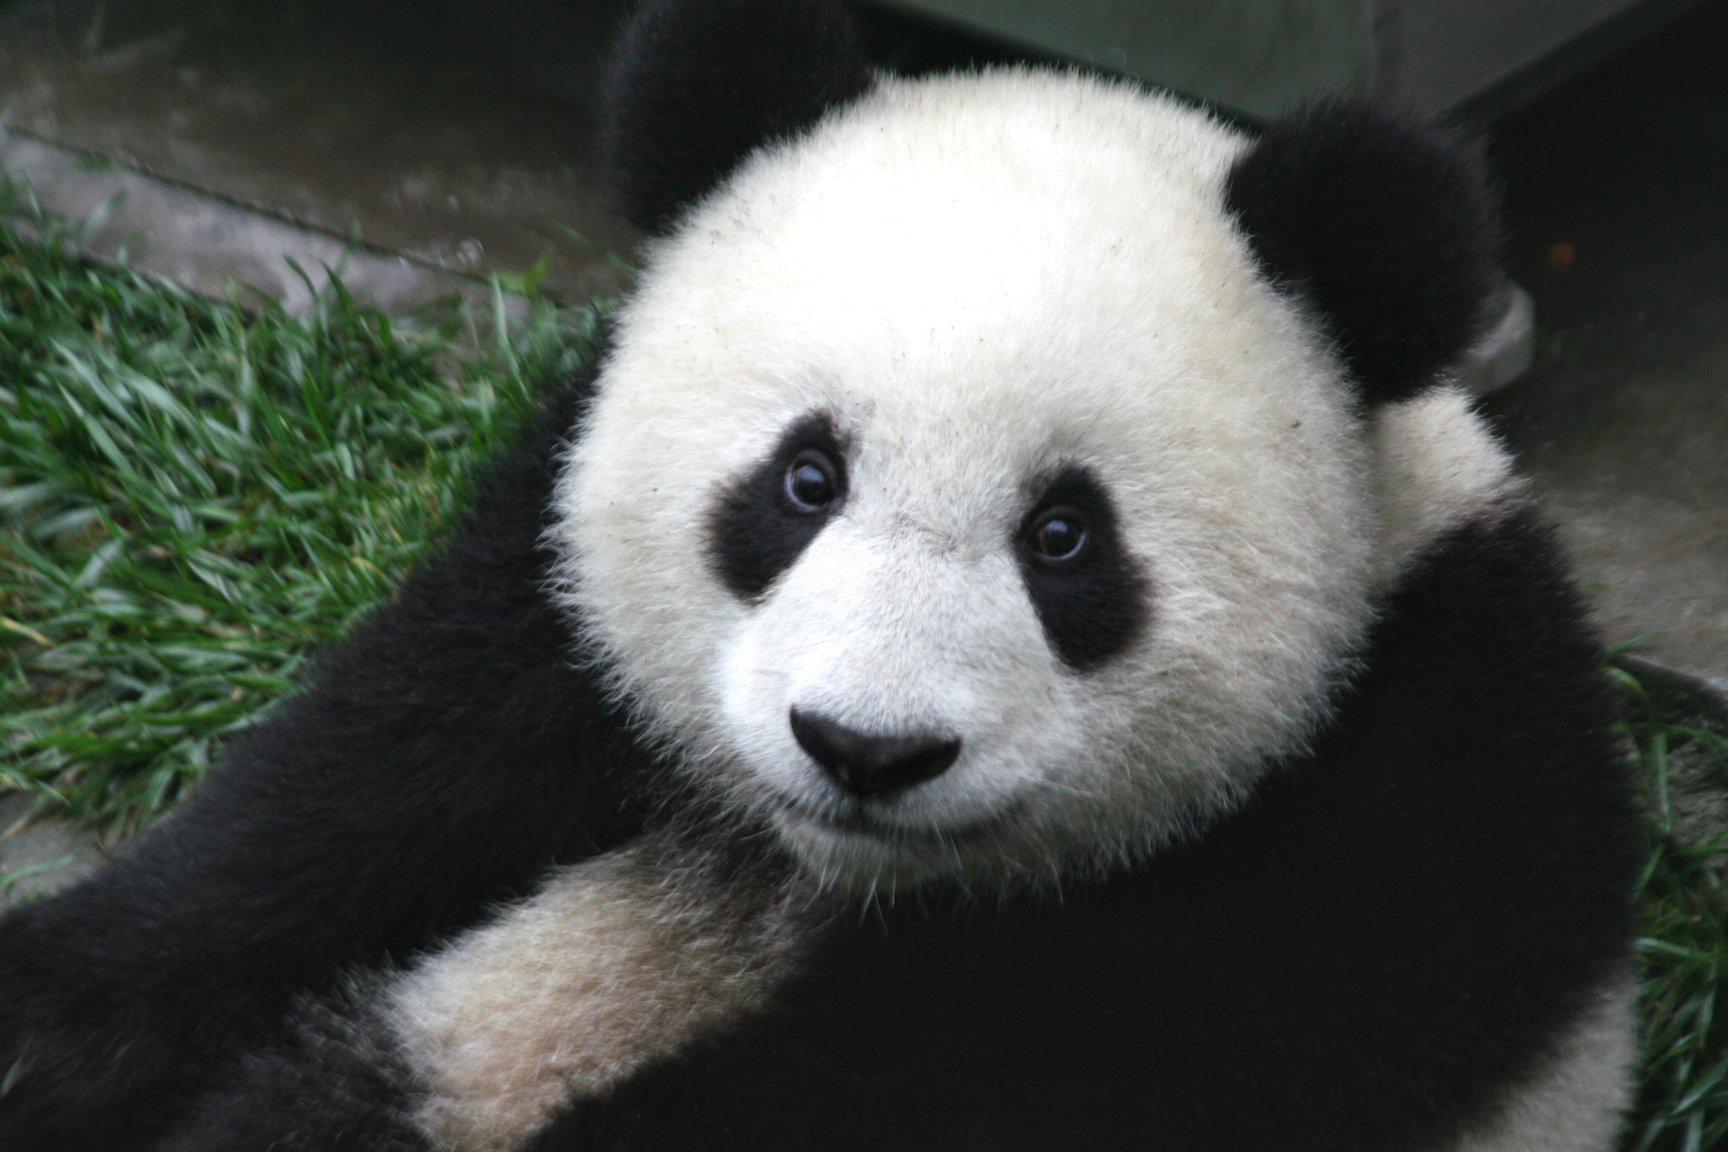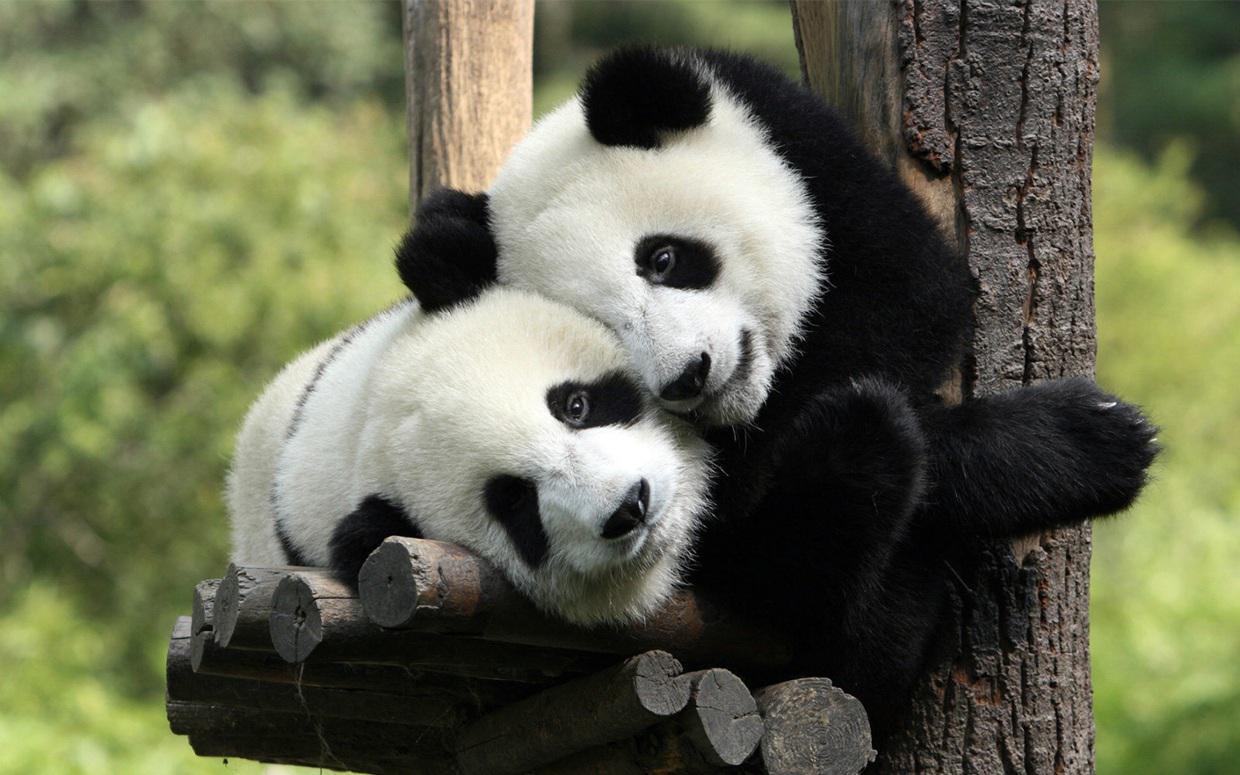The first image is the image on the left, the second image is the image on the right. Given the left and right images, does the statement "There are two pandas in one of the pictures." hold true? Answer yes or no. Yes. 